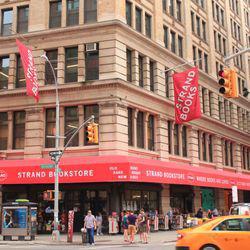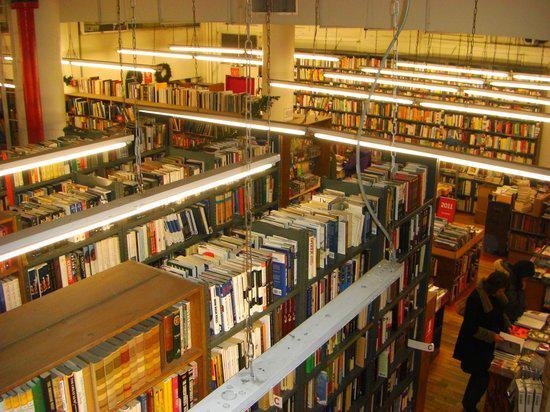The first image is the image on the left, the second image is the image on the right. Examine the images to the left and right. Is the description "Red rectangular signs with white lettering are displayed above ground-level in one scene." accurate? Answer yes or no. Yes. 